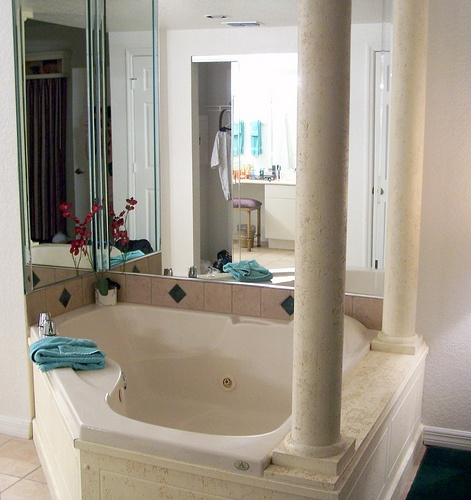Describe the objects in this image and their specific colors. I can see sink in lightgray, gray, darkgray, and tan tones, potted plant in lightgray, black, maroon, and gray tones, and chair in lightgray, darkgray, gray, and olive tones in this image. 